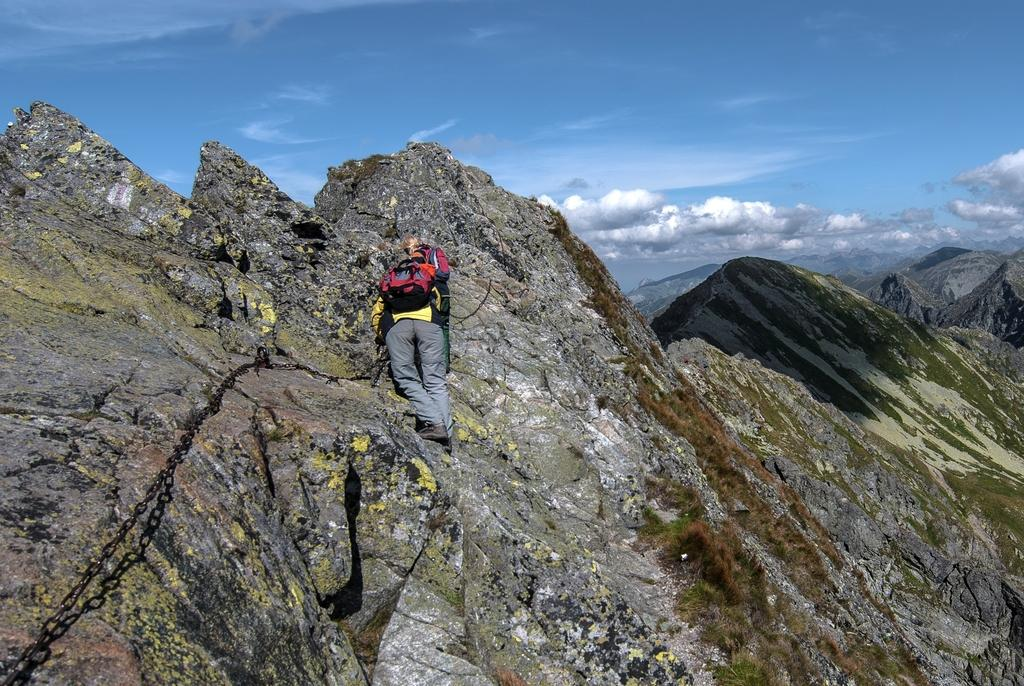What is the main action being performed by the person in the image? There is a person climbing a hill in the image. What type of landscape can be seen on the right side of the image? There are hills on the right side of the image. What is visible at the top of the image? The sky is visible at the top of the image. What object can be seen on the left side of the image? There is a chain on the left side of the image. How many pens are visible in the image? There are no pens present in the image. What type of town can be seen in the background of the image? There is no town visible in the image; it features a person climbing a hill with hills and a chain in the background. 